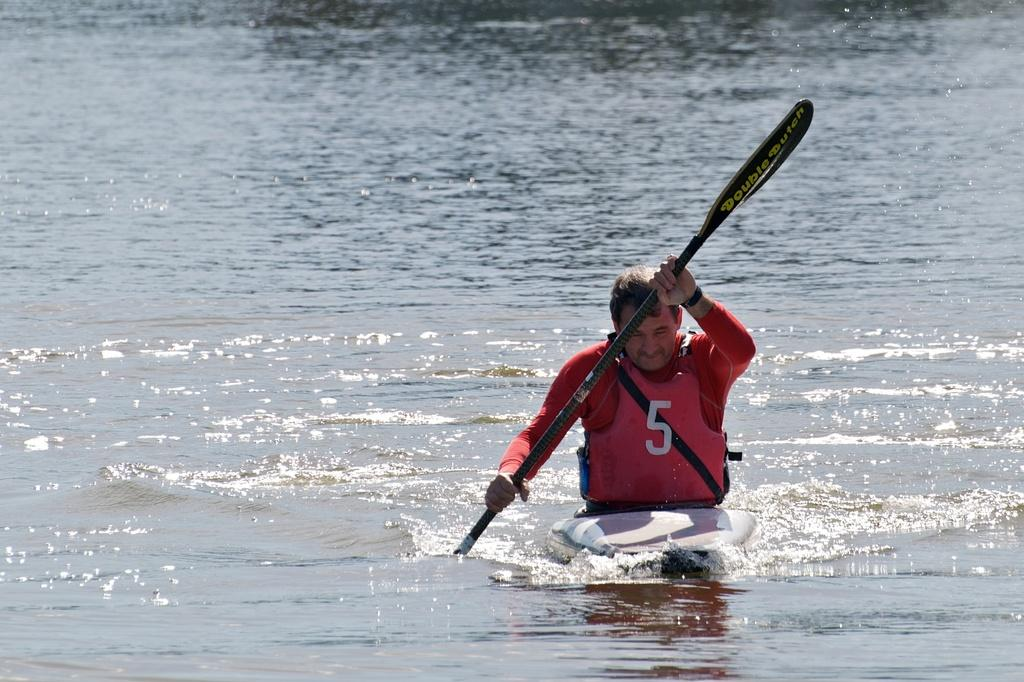Who is present in the image? There is a person in the image. What is the person wearing? The person is wearing a pink jacket. What is the person doing in the image? The person is sitting in a boat. What is the person holding in the image? The person is holding a pedal. Where is the boat located? The boat is on the water. What type of tray is visible in the image? There is there a tray present in the image? 